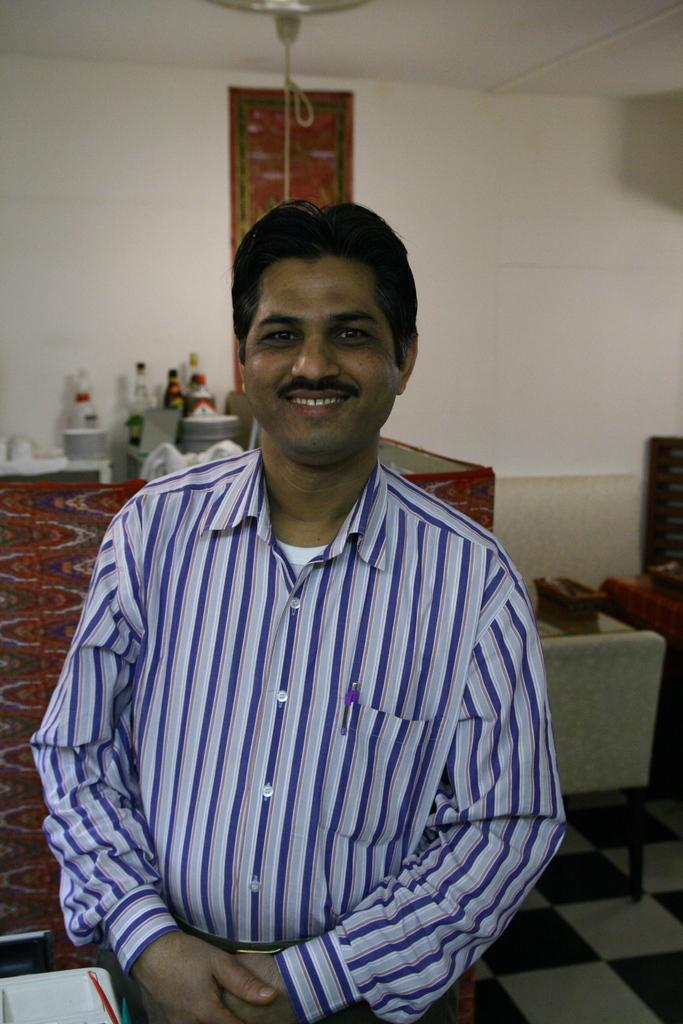What is the person in the image doing? The person is standing in the image and smiling. What can be seen in the background of the image? There is a floor, a chair, a wall, a ceiling, bottles, and other objects visible in the background of the image. Can you describe the person's expression in the image? The person is smiling in the image. What type of zinc is present in the image? There is no zinc present in the image. What is being destroyed in the image? There is no destruction depicted in the image. Is the person in jail in the image? There is no indication in the image that the person is in jail. 